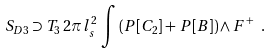Convert formula to latex. <formula><loc_0><loc_0><loc_500><loc_500>S _ { D 3 } \supset T _ { 3 } \, 2 \pi \, l _ { s } ^ { 2 } \, \int \left ( P [ C _ { 2 } ] + \, P [ B ] \right ) \wedge F ^ { + } \ .</formula> 